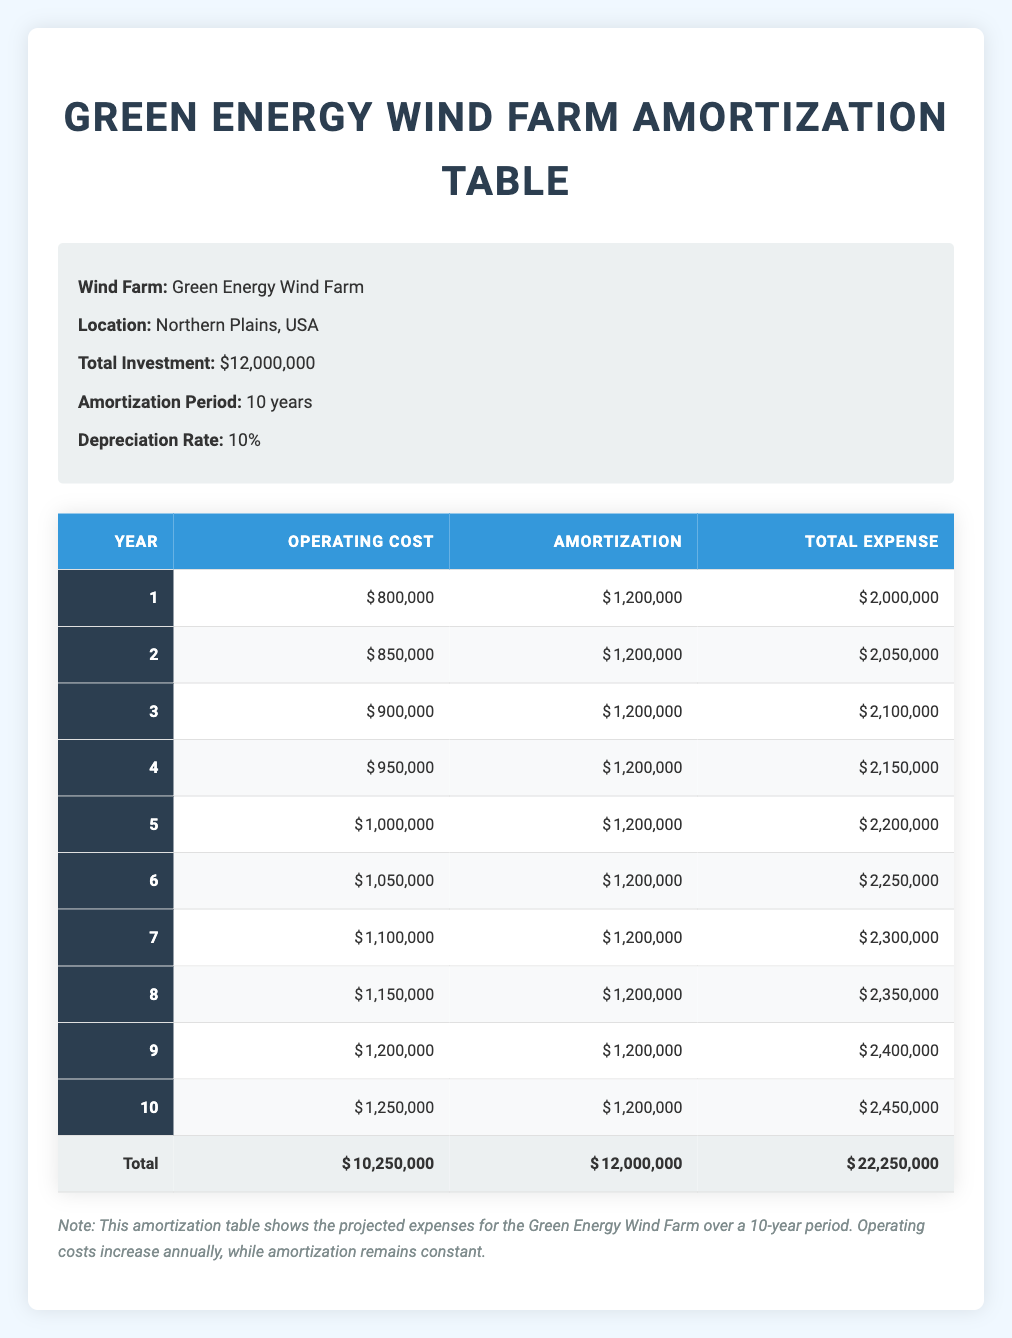What is the total operating cost for year 5? The total operating cost for year 5 is listed in the table, specifically in the "Operating Cost" column for year 5, which is 1,000,000.
Answer: 1,000,000 What was the total expense in year 7? The total expense for year 7 is provided in the "Total Expense" column for that year, which is 2,300,000.
Answer: 2,300,000 What is the annual amortization amount throughout the 10 years? The annual amortization amount is constant at 1,200,000, as shown in the "Amortization" column for all years.
Answer: 1,200,000 What is the total expense over the 10-year period? To find the total expense over the 10 years, add all the values in the "Total Expense" column: (2,000,000 + 2,050,000 + 2,100,000 + 2,150,000 + 2,200,000 + 2,250,000 + 2,300,000 + 2,350,000 + 2,400,000 + 2,450,000) = 22,250,000.
Answer: 22,250,000 In which year did the operating costs exceed 1,000,000 for the first time? The operating costs first exceed 1,000,000 in year 5, as indicated in the "Operating Cost" column where year 5 is listed as 1,000,000. However, year 5 is the first year where that amount is reached, indicating it's the starting point for exceeding one million.
Answer: Year 5 Did the total expenses increase every year? Yes, by examining the "Total Expense" column, each year's total expense is greater than the previous year's, indicating a consistent increase.
Answer: Yes What is the average annual operating cost over the 10-year period? To calculate the average annual operating cost, sum up all the operating costs from the "Operating Cost" column: (800,000 + 850,000 + 900,000 + 950,000 + 1,000,000 + 1,050,000 + 1,100,000 + 1,150,000 + 1,200,000 + 1,250,000) = 10,250,000. Then divide it by the number of years (10): 10,250,000 / 10 = 1,025,000.
Answer: 1,025,000 How much more did the total expense increase from year 1 to year 10? The total expense for year 1 is 2,000,000 and for year 10, it is 2,450,000. To find the difference: 2,450,000 - 2,000,000 = 450,000.
Answer: 450,000 What percentage of the total investment does the total amortization represent? The total amortization over the 10 years is 12,000,000, and the total investment is also 12,000,000. To find the percentage, calculate (12,000,000 / 12,000,000) * 100 = 100%.
Answer: 100% 